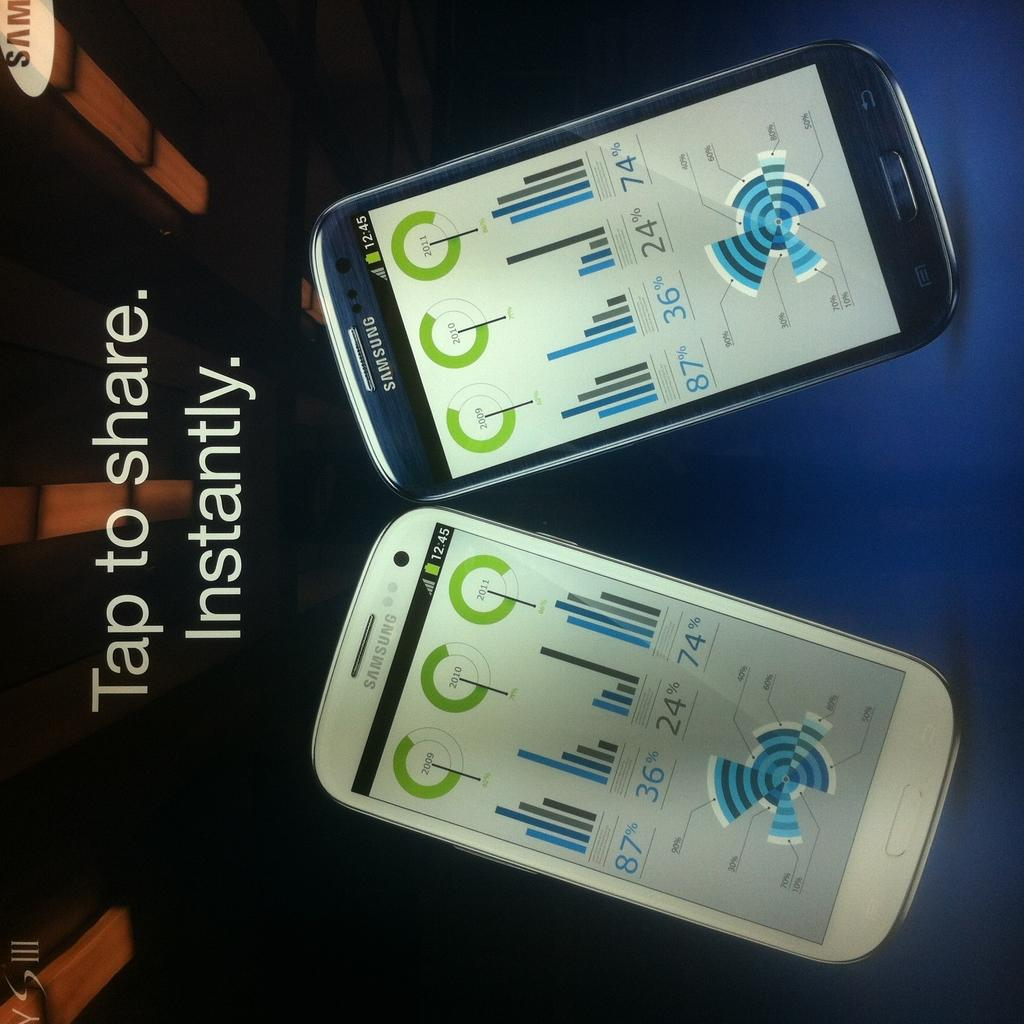What type of visual is the image? The image is a poster. What is shown on the poster? There are mobiles depicted on the poster. Are there any words on the poster? Yes, there is text written on the poster. How many steps are there on the poster? There are no steps depicted on the poster; it features mobiles and text. Can you see any holiday decorations on the poster? There is no mention of holiday decorations in the provided facts, and the image does not show any. 